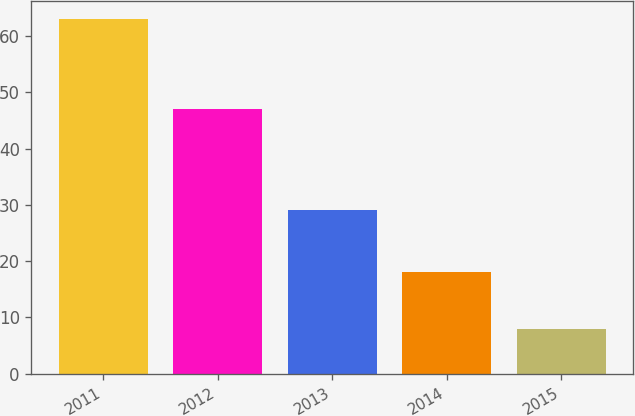Convert chart. <chart><loc_0><loc_0><loc_500><loc_500><bar_chart><fcel>2011<fcel>2012<fcel>2013<fcel>2014<fcel>2015<nl><fcel>63<fcel>47<fcel>29<fcel>18<fcel>8<nl></chart> 